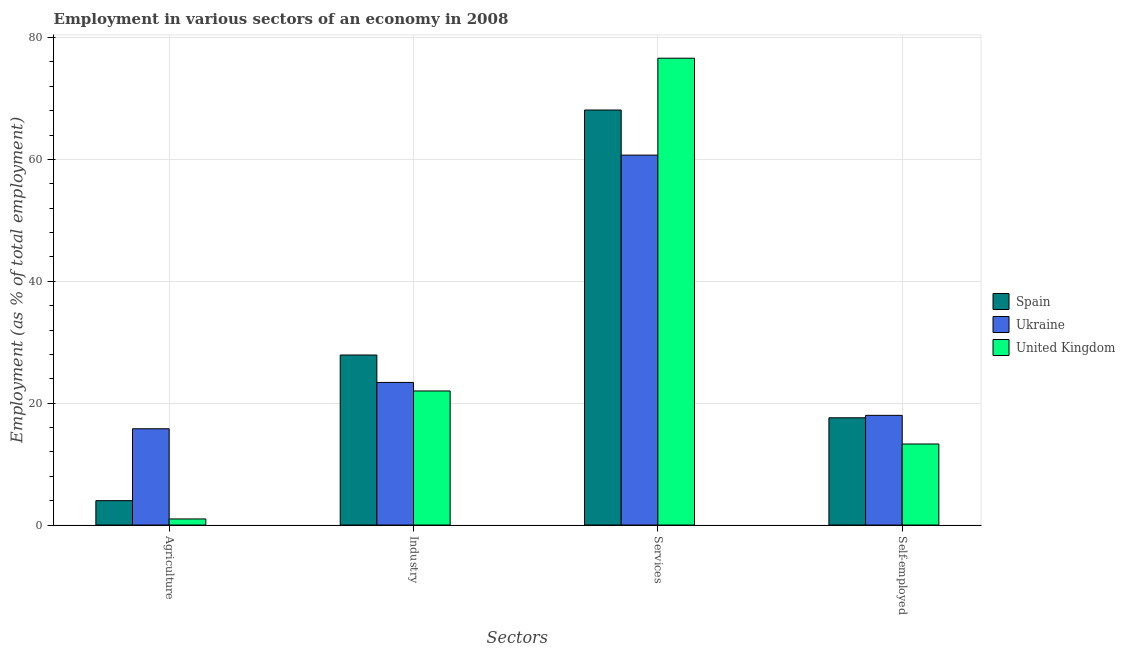How many groups of bars are there?
Offer a very short reply. 4. Are the number of bars per tick equal to the number of legend labels?
Your response must be concise. Yes. What is the label of the 4th group of bars from the left?
Your answer should be very brief. Self-employed. What is the percentage of workers in agriculture in Spain?
Keep it short and to the point. 4. Across all countries, what is the maximum percentage of workers in services?
Make the answer very short. 76.6. Across all countries, what is the minimum percentage of self employed workers?
Your answer should be very brief. 13.3. In which country was the percentage of workers in agriculture maximum?
Keep it short and to the point. Ukraine. In which country was the percentage of self employed workers minimum?
Provide a short and direct response. United Kingdom. What is the total percentage of workers in services in the graph?
Give a very brief answer. 205.4. What is the difference between the percentage of workers in services in Spain and that in Ukraine?
Provide a short and direct response. 7.4. What is the difference between the percentage of workers in agriculture in Spain and the percentage of workers in industry in United Kingdom?
Provide a succinct answer. -18. What is the average percentage of workers in industry per country?
Offer a terse response. 24.43. What is the difference between the percentage of workers in services and percentage of workers in agriculture in Ukraine?
Keep it short and to the point. 44.9. In how many countries, is the percentage of self employed workers greater than 16 %?
Offer a very short reply. 2. What is the ratio of the percentage of workers in industry in United Kingdom to that in Ukraine?
Give a very brief answer. 0.94. Is the difference between the percentage of workers in agriculture in Ukraine and United Kingdom greater than the difference between the percentage of self employed workers in Ukraine and United Kingdom?
Ensure brevity in your answer.  Yes. What is the difference between the highest and the second highest percentage of self employed workers?
Your response must be concise. 0.4. What is the difference between the highest and the lowest percentage of workers in services?
Your answer should be very brief. 15.9. Is the sum of the percentage of self employed workers in Ukraine and Spain greater than the maximum percentage of workers in agriculture across all countries?
Keep it short and to the point. Yes. What does the 3rd bar from the right in Industry represents?
Your answer should be compact. Spain. Where does the legend appear in the graph?
Keep it short and to the point. Center right. How are the legend labels stacked?
Your response must be concise. Vertical. What is the title of the graph?
Offer a terse response. Employment in various sectors of an economy in 2008. Does "Central Europe" appear as one of the legend labels in the graph?
Offer a very short reply. No. What is the label or title of the X-axis?
Give a very brief answer. Sectors. What is the label or title of the Y-axis?
Make the answer very short. Employment (as % of total employment). What is the Employment (as % of total employment) of Ukraine in Agriculture?
Offer a very short reply. 15.8. What is the Employment (as % of total employment) in United Kingdom in Agriculture?
Your answer should be very brief. 1. What is the Employment (as % of total employment) of Spain in Industry?
Offer a terse response. 27.9. What is the Employment (as % of total employment) in Ukraine in Industry?
Ensure brevity in your answer.  23.4. What is the Employment (as % of total employment) of United Kingdom in Industry?
Ensure brevity in your answer.  22. What is the Employment (as % of total employment) of Spain in Services?
Your answer should be very brief. 68.1. What is the Employment (as % of total employment) in Ukraine in Services?
Your response must be concise. 60.7. What is the Employment (as % of total employment) in United Kingdom in Services?
Ensure brevity in your answer.  76.6. What is the Employment (as % of total employment) in Spain in Self-employed?
Your response must be concise. 17.6. What is the Employment (as % of total employment) of Ukraine in Self-employed?
Your answer should be compact. 18. What is the Employment (as % of total employment) in United Kingdom in Self-employed?
Your answer should be very brief. 13.3. Across all Sectors, what is the maximum Employment (as % of total employment) of Spain?
Keep it short and to the point. 68.1. Across all Sectors, what is the maximum Employment (as % of total employment) of Ukraine?
Provide a short and direct response. 60.7. Across all Sectors, what is the maximum Employment (as % of total employment) of United Kingdom?
Give a very brief answer. 76.6. Across all Sectors, what is the minimum Employment (as % of total employment) in Ukraine?
Provide a succinct answer. 15.8. What is the total Employment (as % of total employment) of Spain in the graph?
Offer a terse response. 117.6. What is the total Employment (as % of total employment) of Ukraine in the graph?
Give a very brief answer. 117.9. What is the total Employment (as % of total employment) in United Kingdom in the graph?
Provide a short and direct response. 112.9. What is the difference between the Employment (as % of total employment) of Spain in Agriculture and that in Industry?
Provide a short and direct response. -23.9. What is the difference between the Employment (as % of total employment) of United Kingdom in Agriculture and that in Industry?
Offer a terse response. -21. What is the difference between the Employment (as % of total employment) of Spain in Agriculture and that in Services?
Your answer should be very brief. -64.1. What is the difference between the Employment (as % of total employment) in Ukraine in Agriculture and that in Services?
Ensure brevity in your answer.  -44.9. What is the difference between the Employment (as % of total employment) in United Kingdom in Agriculture and that in Services?
Provide a succinct answer. -75.6. What is the difference between the Employment (as % of total employment) in Spain in Agriculture and that in Self-employed?
Offer a very short reply. -13.6. What is the difference between the Employment (as % of total employment) of United Kingdom in Agriculture and that in Self-employed?
Provide a short and direct response. -12.3. What is the difference between the Employment (as % of total employment) in Spain in Industry and that in Services?
Keep it short and to the point. -40.2. What is the difference between the Employment (as % of total employment) of Ukraine in Industry and that in Services?
Your response must be concise. -37.3. What is the difference between the Employment (as % of total employment) of United Kingdom in Industry and that in Services?
Make the answer very short. -54.6. What is the difference between the Employment (as % of total employment) of Spain in Services and that in Self-employed?
Ensure brevity in your answer.  50.5. What is the difference between the Employment (as % of total employment) of Ukraine in Services and that in Self-employed?
Your response must be concise. 42.7. What is the difference between the Employment (as % of total employment) of United Kingdom in Services and that in Self-employed?
Your response must be concise. 63.3. What is the difference between the Employment (as % of total employment) in Spain in Agriculture and the Employment (as % of total employment) in Ukraine in Industry?
Offer a terse response. -19.4. What is the difference between the Employment (as % of total employment) of Spain in Agriculture and the Employment (as % of total employment) of United Kingdom in Industry?
Provide a succinct answer. -18. What is the difference between the Employment (as % of total employment) of Spain in Agriculture and the Employment (as % of total employment) of Ukraine in Services?
Offer a terse response. -56.7. What is the difference between the Employment (as % of total employment) of Spain in Agriculture and the Employment (as % of total employment) of United Kingdom in Services?
Offer a terse response. -72.6. What is the difference between the Employment (as % of total employment) in Ukraine in Agriculture and the Employment (as % of total employment) in United Kingdom in Services?
Provide a succinct answer. -60.8. What is the difference between the Employment (as % of total employment) of Spain in Agriculture and the Employment (as % of total employment) of United Kingdom in Self-employed?
Provide a short and direct response. -9.3. What is the difference between the Employment (as % of total employment) in Spain in Industry and the Employment (as % of total employment) in Ukraine in Services?
Your answer should be compact. -32.8. What is the difference between the Employment (as % of total employment) in Spain in Industry and the Employment (as % of total employment) in United Kingdom in Services?
Offer a very short reply. -48.7. What is the difference between the Employment (as % of total employment) in Ukraine in Industry and the Employment (as % of total employment) in United Kingdom in Services?
Keep it short and to the point. -53.2. What is the difference between the Employment (as % of total employment) in Spain in Industry and the Employment (as % of total employment) in Ukraine in Self-employed?
Your response must be concise. 9.9. What is the difference between the Employment (as % of total employment) in Ukraine in Industry and the Employment (as % of total employment) in United Kingdom in Self-employed?
Offer a terse response. 10.1. What is the difference between the Employment (as % of total employment) in Spain in Services and the Employment (as % of total employment) in Ukraine in Self-employed?
Your response must be concise. 50.1. What is the difference between the Employment (as % of total employment) in Spain in Services and the Employment (as % of total employment) in United Kingdom in Self-employed?
Your answer should be very brief. 54.8. What is the difference between the Employment (as % of total employment) of Ukraine in Services and the Employment (as % of total employment) of United Kingdom in Self-employed?
Make the answer very short. 47.4. What is the average Employment (as % of total employment) in Spain per Sectors?
Ensure brevity in your answer.  29.4. What is the average Employment (as % of total employment) of Ukraine per Sectors?
Offer a very short reply. 29.48. What is the average Employment (as % of total employment) of United Kingdom per Sectors?
Your answer should be very brief. 28.23. What is the difference between the Employment (as % of total employment) in Spain and Employment (as % of total employment) in Ukraine in Industry?
Offer a very short reply. 4.5. What is the difference between the Employment (as % of total employment) of Ukraine and Employment (as % of total employment) of United Kingdom in Industry?
Give a very brief answer. 1.4. What is the difference between the Employment (as % of total employment) in Spain and Employment (as % of total employment) in Ukraine in Services?
Keep it short and to the point. 7.4. What is the difference between the Employment (as % of total employment) of Ukraine and Employment (as % of total employment) of United Kingdom in Services?
Ensure brevity in your answer.  -15.9. What is the difference between the Employment (as % of total employment) of Ukraine and Employment (as % of total employment) of United Kingdom in Self-employed?
Ensure brevity in your answer.  4.7. What is the ratio of the Employment (as % of total employment) in Spain in Agriculture to that in Industry?
Your answer should be compact. 0.14. What is the ratio of the Employment (as % of total employment) of Ukraine in Agriculture to that in Industry?
Offer a terse response. 0.68. What is the ratio of the Employment (as % of total employment) of United Kingdom in Agriculture to that in Industry?
Your answer should be very brief. 0.05. What is the ratio of the Employment (as % of total employment) in Spain in Agriculture to that in Services?
Offer a terse response. 0.06. What is the ratio of the Employment (as % of total employment) of Ukraine in Agriculture to that in Services?
Your answer should be compact. 0.26. What is the ratio of the Employment (as % of total employment) of United Kingdom in Agriculture to that in Services?
Ensure brevity in your answer.  0.01. What is the ratio of the Employment (as % of total employment) in Spain in Agriculture to that in Self-employed?
Your answer should be compact. 0.23. What is the ratio of the Employment (as % of total employment) in Ukraine in Agriculture to that in Self-employed?
Your answer should be very brief. 0.88. What is the ratio of the Employment (as % of total employment) in United Kingdom in Agriculture to that in Self-employed?
Your answer should be very brief. 0.08. What is the ratio of the Employment (as % of total employment) of Spain in Industry to that in Services?
Your answer should be very brief. 0.41. What is the ratio of the Employment (as % of total employment) in Ukraine in Industry to that in Services?
Provide a succinct answer. 0.39. What is the ratio of the Employment (as % of total employment) in United Kingdom in Industry to that in Services?
Keep it short and to the point. 0.29. What is the ratio of the Employment (as % of total employment) of Spain in Industry to that in Self-employed?
Your answer should be very brief. 1.59. What is the ratio of the Employment (as % of total employment) in Ukraine in Industry to that in Self-employed?
Provide a short and direct response. 1.3. What is the ratio of the Employment (as % of total employment) in United Kingdom in Industry to that in Self-employed?
Provide a succinct answer. 1.65. What is the ratio of the Employment (as % of total employment) in Spain in Services to that in Self-employed?
Give a very brief answer. 3.87. What is the ratio of the Employment (as % of total employment) of Ukraine in Services to that in Self-employed?
Your answer should be compact. 3.37. What is the ratio of the Employment (as % of total employment) of United Kingdom in Services to that in Self-employed?
Provide a short and direct response. 5.76. What is the difference between the highest and the second highest Employment (as % of total employment) in Spain?
Offer a very short reply. 40.2. What is the difference between the highest and the second highest Employment (as % of total employment) in Ukraine?
Keep it short and to the point. 37.3. What is the difference between the highest and the second highest Employment (as % of total employment) in United Kingdom?
Ensure brevity in your answer.  54.6. What is the difference between the highest and the lowest Employment (as % of total employment) in Spain?
Make the answer very short. 64.1. What is the difference between the highest and the lowest Employment (as % of total employment) of Ukraine?
Ensure brevity in your answer.  44.9. What is the difference between the highest and the lowest Employment (as % of total employment) in United Kingdom?
Provide a short and direct response. 75.6. 